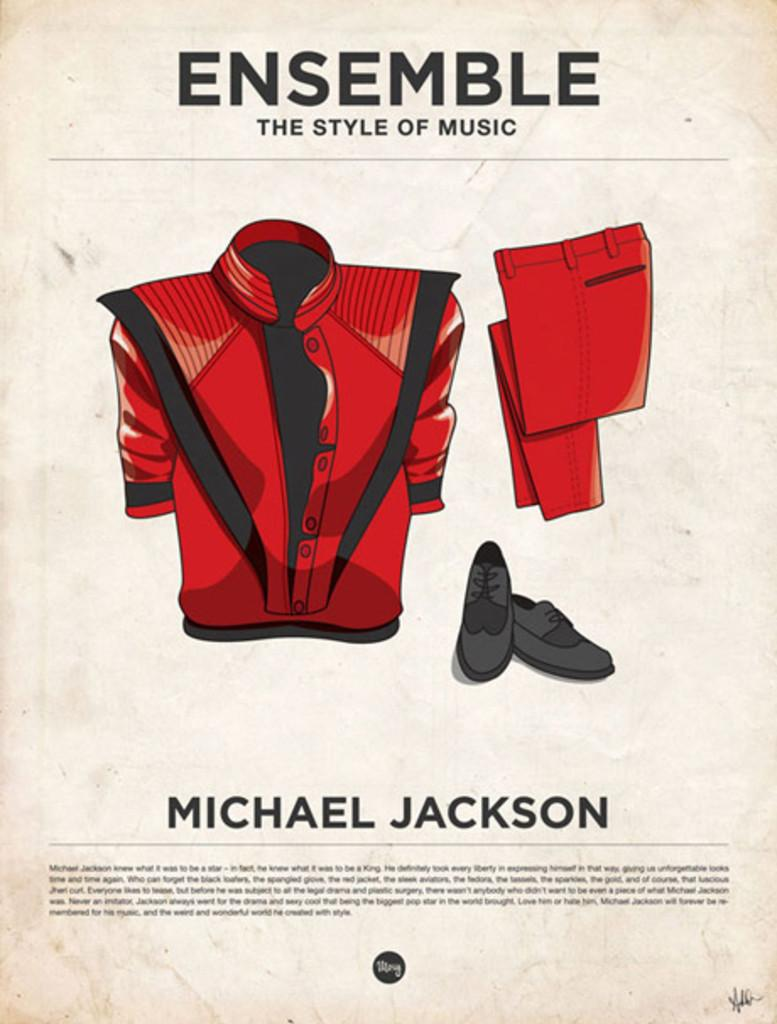<image>
Describe the image concisely. A poster that has a red suit on it says Michael Jackson. 